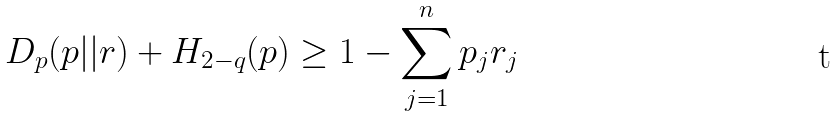Convert formula to latex. <formula><loc_0><loc_0><loc_500><loc_500>D _ { p } ( p | | r ) + H _ { 2 - q } ( p ) \geq 1 - \sum _ { j = 1 } ^ { n } p _ { j } r _ { j }</formula> 